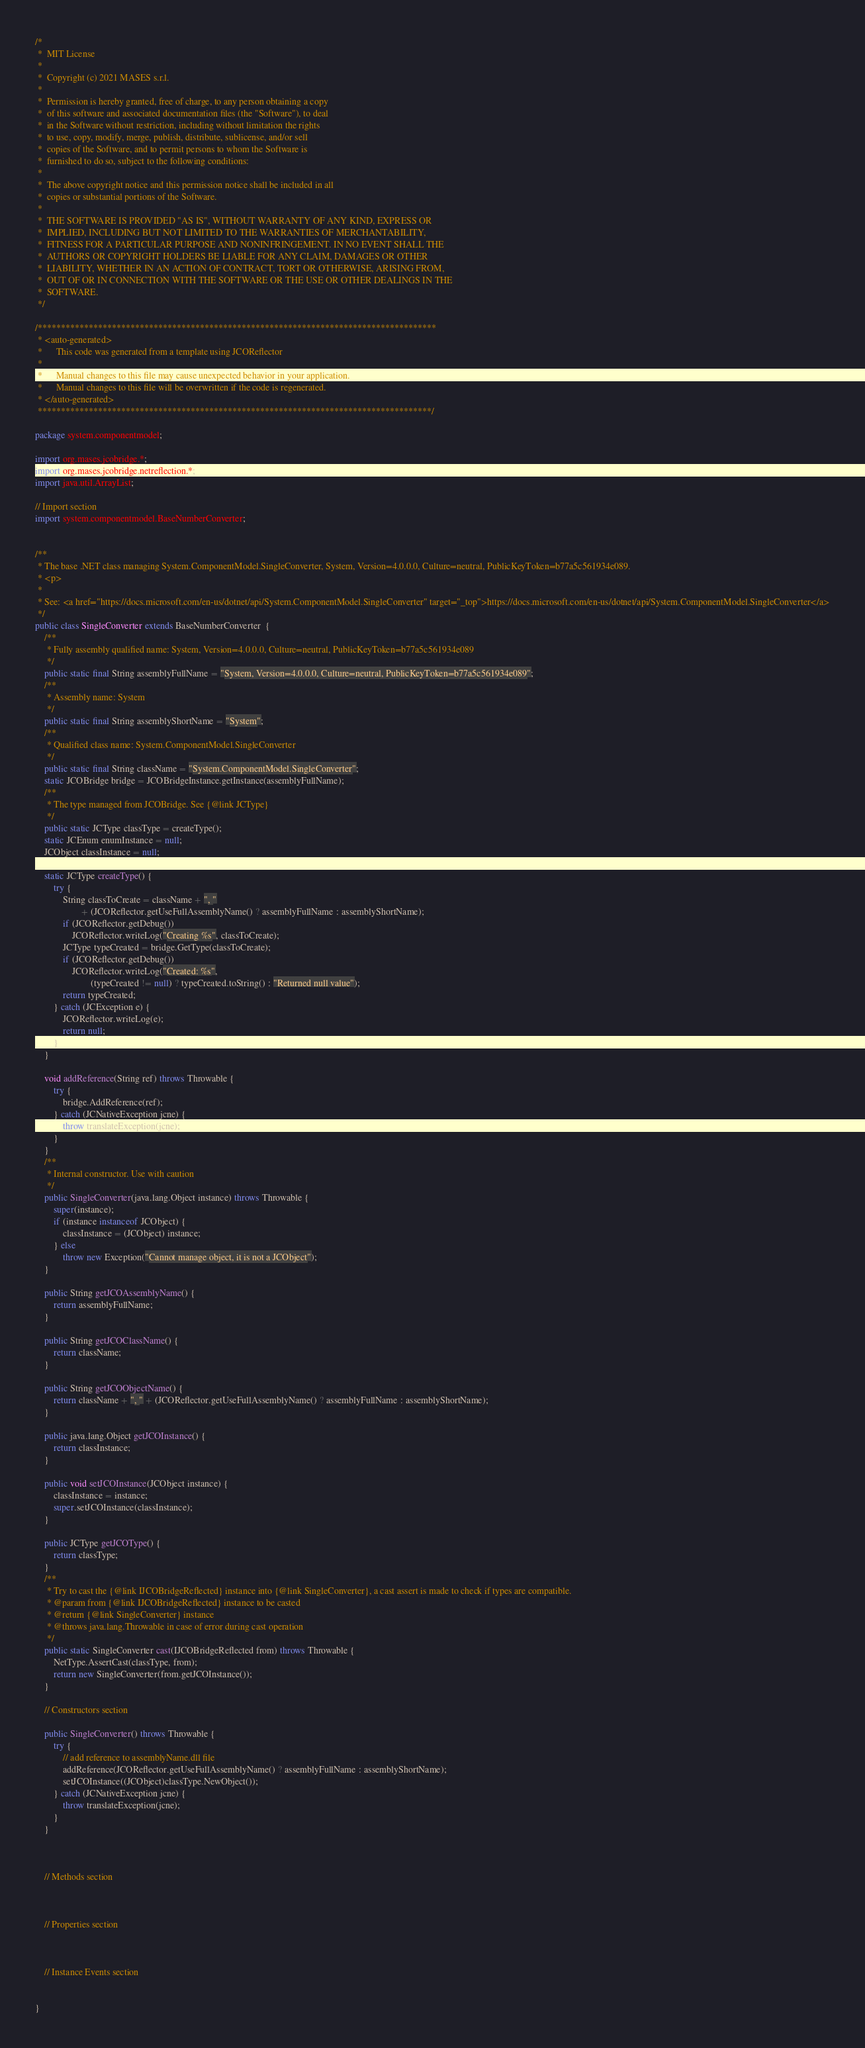<code> <loc_0><loc_0><loc_500><loc_500><_Java_>/*
 *  MIT License
 *
 *  Copyright (c) 2021 MASES s.r.l.
 *
 *  Permission is hereby granted, free of charge, to any person obtaining a copy
 *  of this software and associated documentation files (the "Software"), to deal
 *  in the Software without restriction, including without limitation the rights
 *  to use, copy, modify, merge, publish, distribute, sublicense, and/or sell
 *  copies of the Software, and to permit persons to whom the Software is
 *  furnished to do so, subject to the following conditions:
 *
 *  The above copyright notice and this permission notice shall be included in all
 *  copies or substantial portions of the Software.
 *
 *  THE SOFTWARE IS PROVIDED "AS IS", WITHOUT WARRANTY OF ANY KIND, EXPRESS OR
 *  IMPLIED, INCLUDING BUT NOT LIMITED TO THE WARRANTIES OF MERCHANTABILITY,
 *  FITNESS FOR A PARTICULAR PURPOSE AND NONINFRINGEMENT. IN NO EVENT SHALL THE
 *  AUTHORS OR COPYRIGHT HOLDERS BE LIABLE FOR ANY CLAIM, DAMAGES OR OTHER
 *  LIABILITY, WHETHER IN AN ACTION OF CONTRACT, TORT OR OTHERWISE, ARISING FROM,
 *  OUT OF OR IN CONNECTION WITH THE SOFTWARE OR THE USE OR OTHER DEALINGS IN THE
 *  SOFTWARE.
 */

/**************************************************************************************
 * <auto-generated>
 *      This code was generated from a template using JCOReflector
 * 
 *      Manual changes to this file may cause unexpected behavior in your application.
 *      Manual changes to this file will be overwritten if the code is regenerated.
 * </auto-generated>
 *************************************************************************************/

package system.componentmodel;

import org.mases.jcobridge.*;
import org.mases.jcobridge.netreflection.*;
import java.util.ArrayList;

// Import section
import system.componentmodel.BaseNumberConverter;


/**
 * The base .NET class managing System.ComponentModel.SingleConverter, System, Version=4.0.0.0, Culture=neutral, PublicKeyToken=b77a5c561934e089.
 * <p>
 * 
 * See: <a href="https://docs.microsoft.com/en-us/dotnet/api/System.ComponentModel.SingleConverter" target="_top">https://docs.microsoft.com/en-us/dotnet/api/System.ComponentModel.SingleConverter</a>
 */
public class SingleConverter extends BaseNumberConverter  {
    /**
     * Fully assembly qualified name: System, Version=4.0.0.0, Culture=neutral, PublicKeyToken=b77a5c561934e089
     */
    public static final String assemblyFullName = "System, Version=4.0.0.0, Culture=neutral, PublicKeyToken=b77a5c561934e089";
    /**
     * Assembly name: System
     */
    public static final String assemblyShortName = "System";
    /**
     * Qualified class name: System.ComponentModel.SingleConverter
     */
    public static final String className = "System.ComponentModel.SingleConverter";
    static JCOBridge bridge = JCOBridgeInstance.getInstance(assemblyFullName);
    /**
     * The type managed from JCOBridge. See {@link JCType}
     */
    public static JCType classType = createType();
    static JCEnum enumInstance = null;
    JCObject classInstance = null;

    static JCType createType() {
        try {
            String classToCreate = className + ", "
                    + (JCOReflector.getUseFullAssemblyName() ? assemblyFullName : assemblyShortName);
            if (JCOReflector.getDebug())
                JCOReflector.writeLog("Creating %s", classToCreate);
            JCType typeCreated = bridge.GetType(classToCreate);
            if (JCOReflector.getDebug())
                JCOReflector.writeLog("Created: %s",
                        (typeCreated != null) ? typeCreated.toString() : "Returned null value");
            return typeCreated;
        } catch (JCException e) {
            JCOReflector.writeLog(e);
            return null;
        }
    }

    void addReference(String ref) throws Throwable {
        try {
            bridge.AddReference(ref);
        } catch (JCNativeException jcne) {
            throw translateException(jcne);
        }
    }
    /**
     * Internal constructor. Use with caution 
     */
    public SingleConverter(java.lang.Object instance) throws Throwable {
        super(instance);
        if (instance instanceof JCObject) {
            classInstance = (JCObject) instance;
        } else
            throw new Exception("Cannot manage object, it is not a JCObject");
    }

    public String getJCOAssemblyName() {
        return assemblyFullName;
    }

    public String getJCOClassName() {
        return className;
    }

    public String getJCOObjectName() {
        return className + ", " + (JCOReflector.getUseFullAssemblyName() ? assemblyFullName : assemblyShortName);
    }

    public java.lang.Object getJCOInstance() {
        return classInstance;
    }

    public void setJCOInstance(JCObject instance) {
        classInstance = instance;
        super.setJCOInstance(classInstance);
    }

    public JCType getJCOType() {
        return classType;
    }
    /**
     * Try to cast the {@link IJCOBridgeReflected} instance into {@link SingleConverter}, a cast assert is made to check if types are compatible.
     * @param from {@link IJCOBridgeReflected} instance to be casted
     * @return {@link SingleConverter} instance
     * @throws java.lang.Throwable in case of error during cast operation
     */
    public static SingleConverter cast(IJCOBridgeReflected from) throws Throwable {
        NetType.AssertCast(classType, from);
        return new SingleConverter(from.getJCOInstance());
    }

    // Constructors section
    
    public SingleConverter() throws Throwable {
        try {
            // add reference to assemblyName.dll file
            addReference(JCOReflector.getUseFullAssemblyName() ? assemblyFullName : assemblyShortName);
            setJCOInstance((JCObject)classType.NewObject());
        } catch (JCNativeException jcne) {
            throw translateException(jcne);
        }
    }


    
    // Methods section
    

    
    // Properties section
    


    // Instance Events section
    

}</code> 